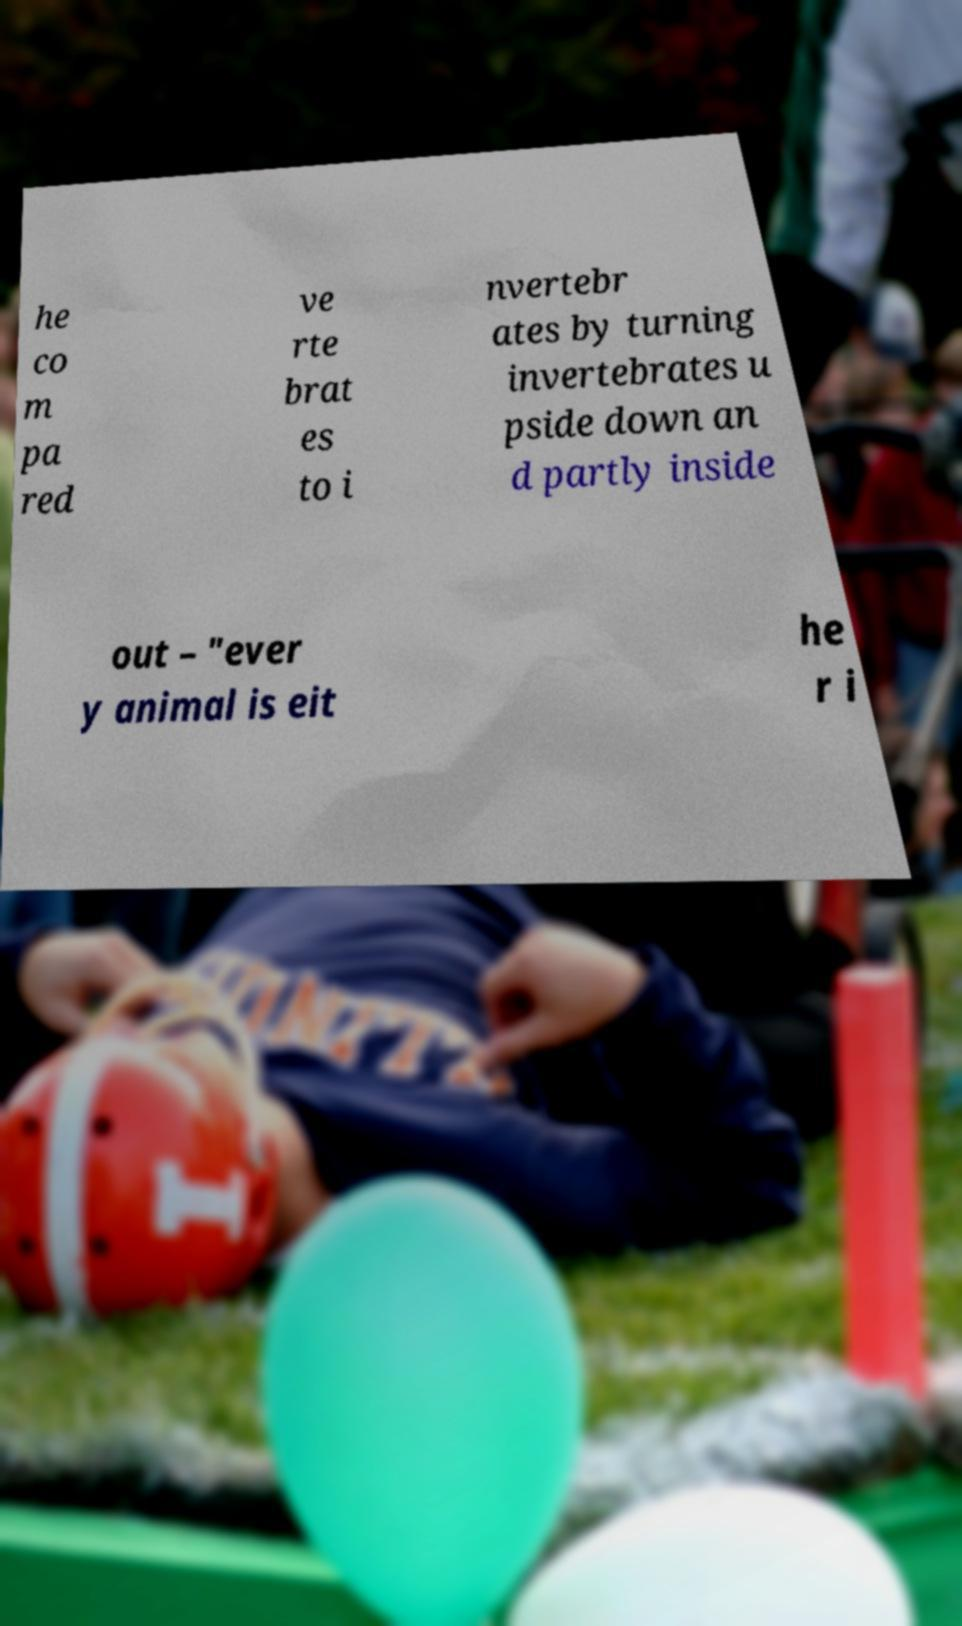Could you extract and type out the text from this image? he co m pa red ve rte brat es to i nvertebr ates by turning invertebrates u pside down an d partly inside out – "ever y animal is eit he r i 